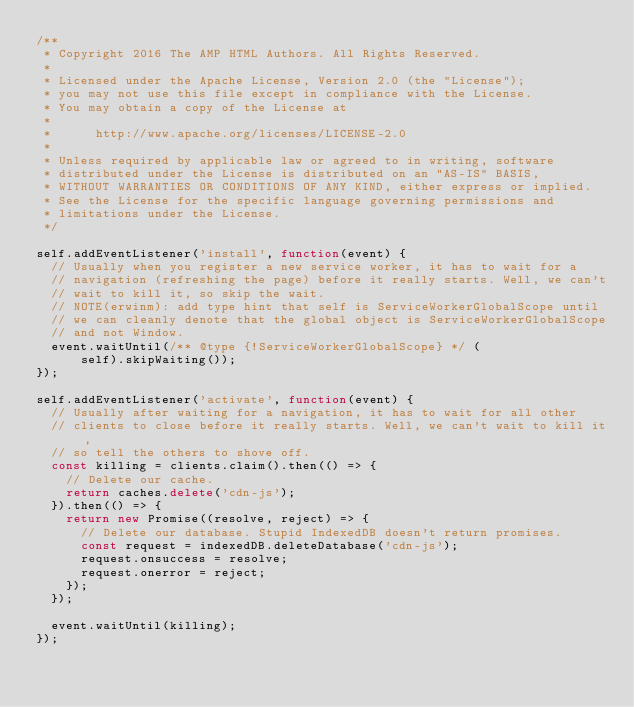<code> <loc_0><loc_0><loc_500><loc_500><_JavaScript_>/**
 * Copyright 2016 The AMP HTML Authors. All Rights Reserved.
 *
 * Licensed under the Apache License, Version 2.0 (the "License");
 * you may not use this file except in compliance with the License.
 * You may obtain a copy of the License at
 *
 *      http://www.apache.org/licenses/LICENSE-2.0
 *
 * Unless required by applicable law or agreed to in writing, software
 * distributed under the License is distributed on an "AS-IS" BASIS,
 * WITHOUT WARRANTIES OR CONDITIONS OF ANY KIND, either express or implied.
 * See the License for the specific language governing permissions and
 * limitations under the License.
 */

self.addEventListener('install', function(event) {
  // Usually when you register a new service worker, it has to wait for a
  // navigation (refreshing the page) before it really starts. Well, we can't
  // wait to kill it, so skip the wait.
  // NOTE(erwinm): add type hint that self is ServiceWorkerGlobalScope until
  // we can cleanly denote that the global object is ServiceWorkerGlobalScope
  // and not Window.
  event.waitUntil(/** @type {!ServiceWorkerGlobalScope} */ (
      self).skipWaiting());
});

self.addEventListener('activate', function(event) {
  // Usually after waiting for a navigation, it has to wait for all other
  // clients to close before it really starts. Well, we can't wait to kill it,
  // so tell the others to shove off.
  const killing = clients.claim().then(() => {
    // Delete our cache.
    return caches.delete('cdn-js');
  }).then(() => {
    return new Promise((resolve, reject) => {
      // Delete our database. Stupid IndexedDB doesn't return promises.
      const request = indexedDB.deleteDatabase('cdn-js');
      request.onsuccess = resolve;
      request.onerror = reject;
    });
  });

  event.waitUntil(killing);
});
</code> 